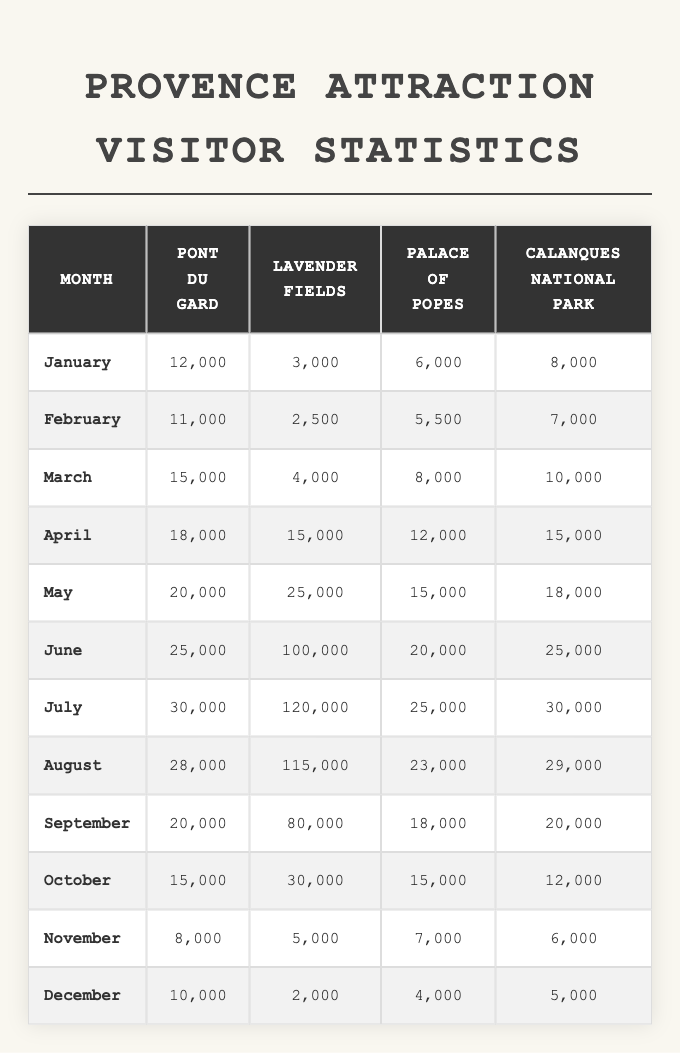What was the highest number of visitors to the Lavender Fields? The highest number of visitors to the Lavender Fields is found in July with 120,000 visitors.
Answer: 120,000 In which month did the Palace of Popes have 6,000 visitors? The Palace of Popes had 6,000 visitors in January, as per the data listed under that month.
Answer: January Which attraction had the least visitors in December? In December, the attraction with the least visitors was the Lavender Fields, which had 2,000 visitors, making it the lowest among all attractions.
Answer: Lavender Fields What is the total number of visitors to Calanques National Park during the summer months (June, July, August)? The total number of visitors to Calanques National Park during these months is 25,000 (June) + 30,000 (July) + 29,000 (August) = 84,000.
Answer: 84,000 How many more visitors did the Pont du Gard receive in May compared to February? The difference can be calculated as 20,000 (May) - 11,000 (February) = 9,000 additional visitors in May compared to February.
Answer: 9,000 Was there an increase in visitors to the Palace of Popes from March to April? Yes, there was an increase from 8,000 visitors in March to 12,000 visitors in April, which indicates an increase.
Answer: Yes What was the average number of visitors to the Calanques National Park in January, October, and December? The calculation is as follows: (8,000 + 12,000 + 5,000) / 3 = 25,000 / 3 = 8,333.33, rounding gives approximately 8,333 visitors on average.
Answer: 8,333 During which month did Lavender Fields see a visitor count below 10,000? The months where Lavender Fields had fewer than 10,000 visitors are January (3,000), February (2,500), and December (2,000).
Answer: January, February, December What was the percentage increase in visitors to the Pont du Gard from March (15,000) to July (30,000)? The percentage increase is calculated as ((30,000 - 15,000) / 15,000) * 100 = 100%, indicating it doubled during this period.
Answer: 100% Is it true that the total visitors to the Lavender Fields in August (115,000) exceeded both the Palace of Popes (23,000) and the Calanques National Park (29,000)? Yes, the total visitors to Lavender Fields in August is indeed greater than those of both the other attractions mentioned.
Answer: Yes 